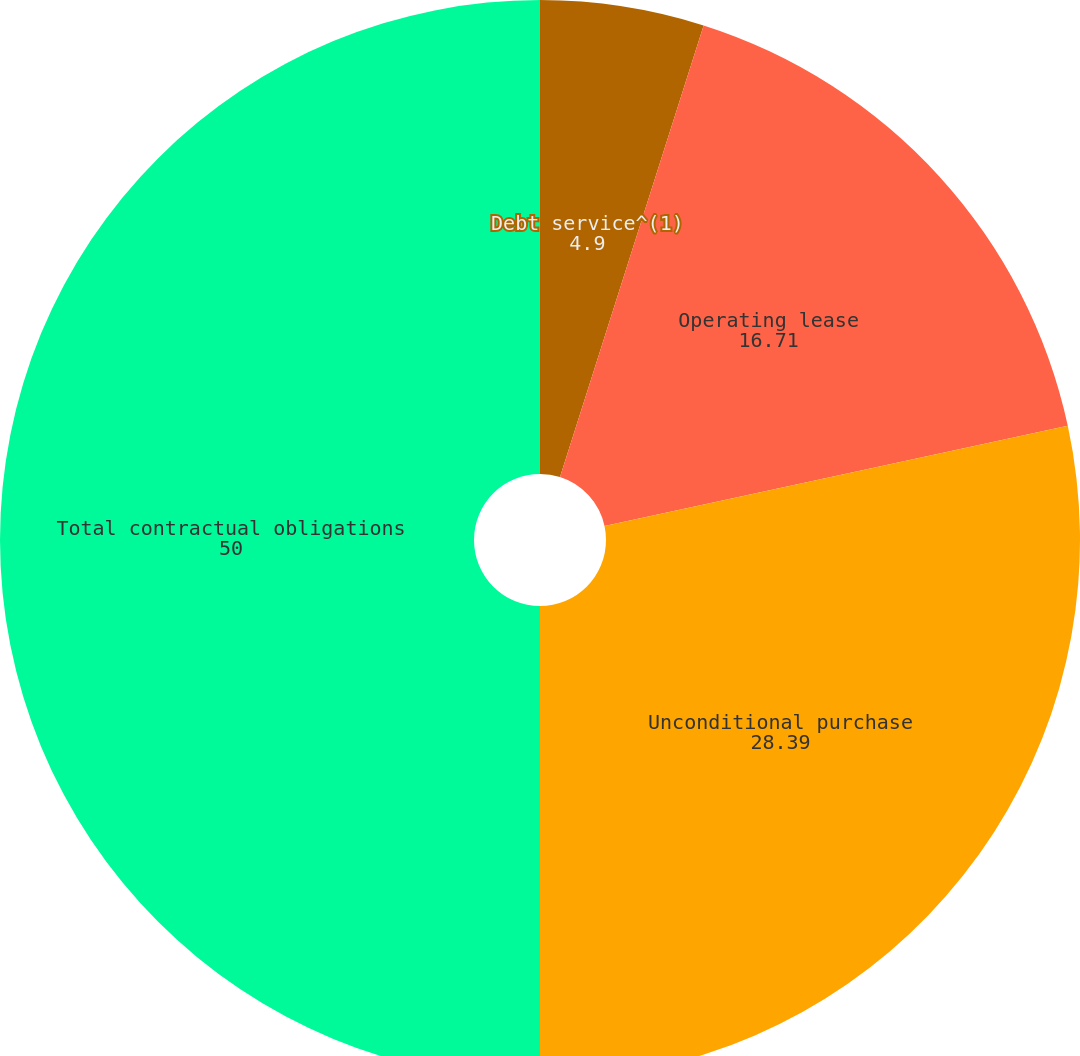Convert chart. <chart><loc_0><loc_0><loc_500><loc_500><pie_chart><fcel>Debt service^(1)<fcel>Operating lease<fcel>Unconditional purchase<fcel>Total contractual obligations<nl><fcel>4.9%<fcel>16.71%<fcel>28.39%<fcel>50.0%<nl></chart> 